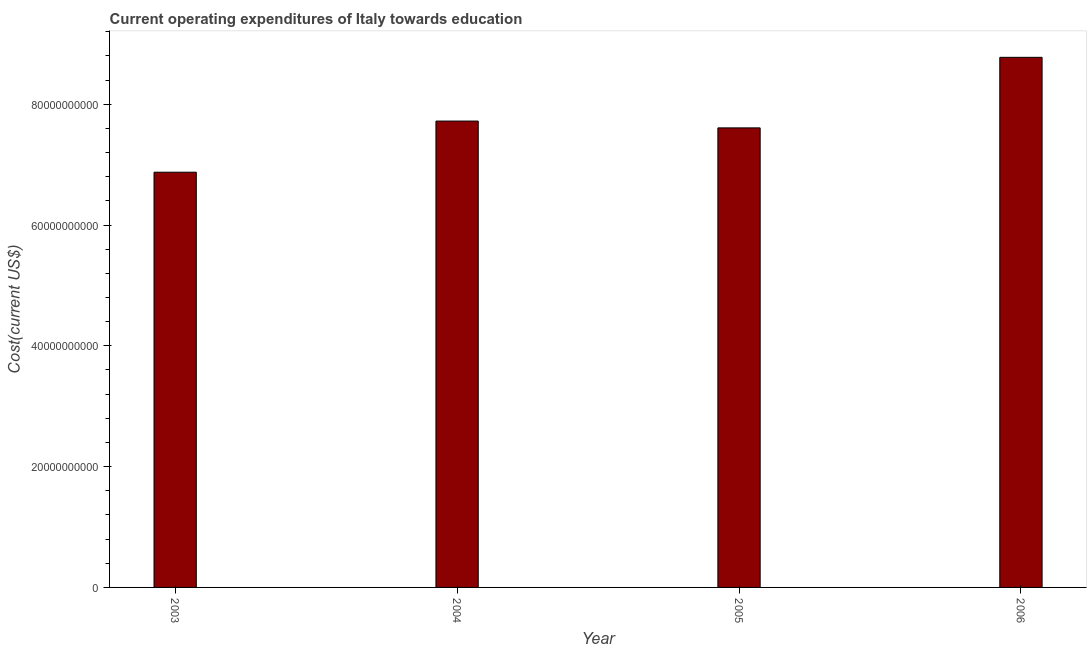Does the graph contain any zero values?
Provide a short and direct response. No. Does the graph contain grids?
Ensure brevity in your answer.  No. What is the title of the graph?
Keep it short and to the point. Current operating expenditures of Italy towards education. What is the label or title of the Y-axis?
Provide a succinct answer. Cost(current US$). What is the education expenditure in 2006?
Provide a succinct answer. 8.78e+1. Across all years, what is the maximum education expenditure?
Your answer should be compact. 8.78e+1. Across all years, what is the minimum education expenditure?
Your response must be concise. 6.87e+1. In which year was the education expenditure minimum?
Give a very brief answer. 2003. What is the sum of the education expenditure?
Ensure brevity in your answer.  3.10e+11. What is the difference between the education expenditure in 2003 and 2006?
Offer a terse response. -1.90e+1. What is the average education expenditure per year?
Offer a very short reply. 7.74e+1. What is the median education expenditure?
Provide a succinct answer. 7.66e+1. In how many years, is the education expenditure greater than 12000000000 US$?
Ensure brevity in your answer.  4. Is the difference between the education expenditure in 2003 and 2005 greater than the difference between any two years?
Give a very brief answer. No. What is the difference between the highest and the second highest education expenditure?
Offer a very short reply. 1.06e+1. Is the sum of the education expenditure in 2005 and 2006 greater than the maximum education expenditure across all years?
Your answer should be very brief. Yes. What is the difference between the highest and the lowest education expenditure?
Provide a short and direct response. 1.90e+1. In how many years, is the education expenditure greater than the average education expenditure taken over all years?
Your response must be concise. 1. How many years are there in the graph?
Keep it short and to the point. 4. Are the values on the major ticks of Y-axis written in scientific E-notation?
Give a very brief answer. No. What is the Cost(current US$) of 2003?
Give a very brief answer. 6.87e+1. What is the Cost(current US$) in 2004?
Your answer should be very brief. 7.72e+1. What is the Cost(current US$) in 2005?
Keep it short and to the point. 7.61e+1. What is the Cost(current US$) of 2006?
Keep it short and to the point. 8.78e+1. What is the difference between the Cost(current US$) in 2003 and 2004?
Give a very brief answer. -8.47e+09. What is the difference between the Cost(current US$) in 2003 and 2005?
Provide a succinct answer. -7.34e+09. What is the difference between the Cost(current US$) in 2003 and 2006?
Offer a terse response. -1.90e+1. What is the difference between the Cost(current US$) in 2004 and 2005?
Your answer should be very brief. 1.13e+09. What is the difference between the Cost(current US$) in 2004 and 2006?
Offer a terse response. -1.06e+1. What is the difference between the Cost(current US$) in 2005 and 2006?
Provide a short and direct response. -1.17e+1. What is the ratio of the Cost(current US$) in 2003 to that in 2004?
Give a very brief answer. 0.89. What is the ratio of the Cost(current US$) in 2003 to that in 2005?
Your response must be concise. 0.9. What is the ratio of the Cost(current US$) in 2003 to that in 2006?
Provide a short and direct response. 0.78. What is the ratio of the Cost(current US$) in 2004 to that in 2006?
Make the answer very short. 0.88. What is the ratio of the Cost(current US$) in 2005 to that in 2006?
Give a very brief answer. 0.87. 